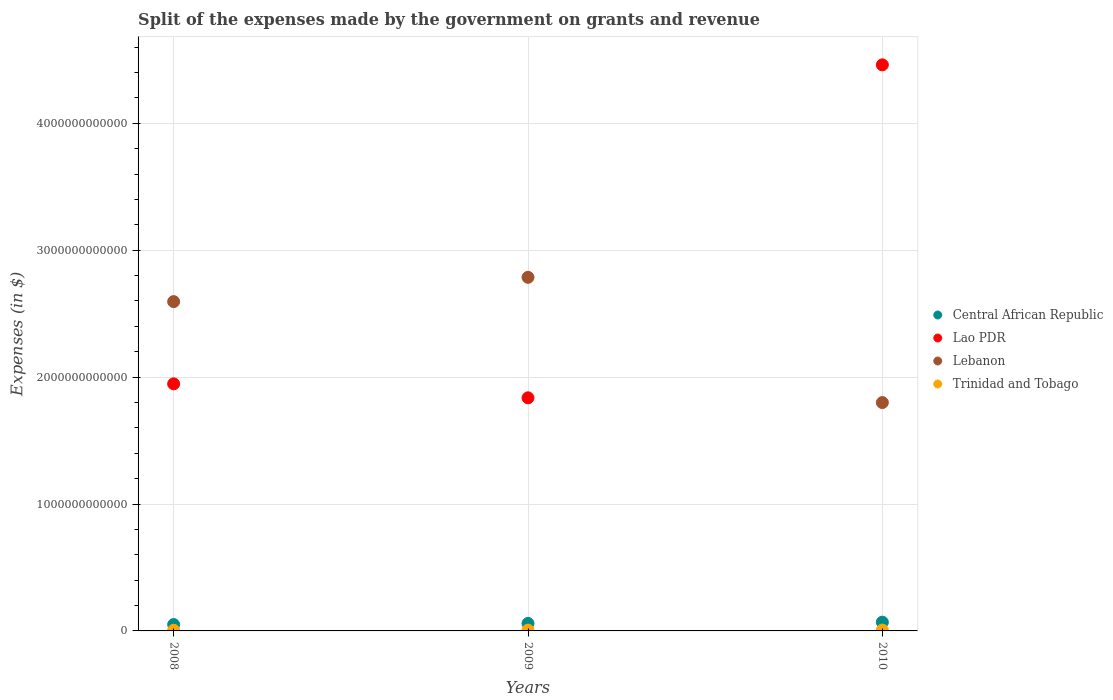Is the number of dotlines equal to the number of legend labels?
Make the answer very short. Yes. What is the expenses made by the government on grants and revenue in Central African Republic in 2008?
Give a very brief answer. 5.01e+1. Across all years, what is the maximum expenses made by the government on grants and revenue in Lao PDR?
Your response must be concise. 4.46e+12. Across all years, what is the minimum expenses made by the government on grants and revenue in Trinidad and Tobago?
Offer a very short reply. 5.11e+09. What is the total expenses made by the government on grants and revenue in Lebanon in the graph?
Ensure brevity in your answer.  7.18e+12. What is the difference between the expenses made by the government on grants and revenue in Lao PDR in 2009 and that in 2010?
Give a very brief answer. -2.62e+12. What is the difference between the expenses made by the government on grants and revenue in Central African Republic in 2009 and the expenses made by the government on grants and revenue in Trinidad and Tobago in 2010?
Keep it short and to the point. 5.21e+1. What is the average expenses made by the government on grants and revenue in Lebanon per year?
Make the answer very short. 2.39e+12. In the year 2008, what is the difference between the expenses made by the government on grants and revenue in Lebanon and expenses made by the government on grants and revenue in Trinidad and Tobago?
Provide a short and direct response. 2.59e+12. What is the ratio of the expenses made by the government on grants and revenue in Lao PDR in 2009 to that in 2010?
Offer a terse response. 0.41. What is the difference between the highest and the second highest expenses made by the government on grants and revenue in Central African Republic?
Your answer should be very brief. 1.01e+1. What is the difference between the highest and the lowest expenses made by the government on grants and revenue in Trinidad and Tobago?
Provide a succinct answer. 1.63e+09. Is it the case that in every year, the sum of the expenses made by the government on grants and revenue in Central African Republic and expenses made by the government on grants and revenue in Trinidad and Tobago  is greater than the expenses made by the government on grants and revenue in Lebanon?
Make the answer very short. No. Does the expenses made by the government on grants and revenue in Lebanon monotonically increase over the years?
Ensure brevity in your answer.  No. Is the expenses made by the government on grants and revenue in Trinidad and Tobago strictly greater than the expenses made by the government on grants and revenue in Lao PDR over the years?
Your answer should be very brief. No. Is the expenses made by the government on grants and revenue in Central African Republic strictly less than the expenses made by the government on grants and revenue in Lao PDR over the years?
Give a very brief answer. Yes. How many dotlines are there?
Keep it short and to the point. 4. What is the difference between two consecutive major ticks on the Y-axis?
Give a very brief answer. 1.00e+12. Are the values on the major ticks of Y-axis written in scientific E-notation?
Make the answer very short. No. Does the graph contain grids?
Provide a short and direct response. Yes. Where does the legend appear in the graph?
Provide a short and direct response. Center right. How many legend labels are there?
Make the answer very short. 4. What is the title of the graph?
Provide a succinct answer. Split of the expenses made by the government on grants and revenue. What is the label or title of the Y-axis?
Your response must be concise. Expenses (in $). What is the Expenses (in $) in Central African Republic in 2008?
Offer a very short reply. 5.01e+1. What is the Expenses (in $) of Lao PDR in 2008?
Provide a short and direct response. 1.95e+12. What is the Expenses (in $) in Lebanon in 2008?
Provide a succinct answer. 2.59e+12. What is the Expenses (in $) in Trinidad and Tobago in 2008?
Your answer should be compact. 5.11e+09. What is the Expenses (in $) of Central African Republic in 2009?
Your answer should be compact. 5.88e+1. What is the Expenses (in $) of Lao PDR in 2009?
Ensure brevity in your answer.  1.84e+12. What is the Expenses (in $) of Lebanon in 2009?
Offer a terse response. 2.79e+12. What is the Expenses (in $) in Trinidad and Tobago in 2009?
Make the answer very short. 6.45e+09. What is the Expenses (in $) of Central African Republic in 2010?
Provide a succinct answer. 6.89e+1. What is the Expenses (in $) in Lao PDR in 2010?
Your answer should be very brief. 4.46e+12. What is the Expenses (in $) in Lebanon in 2010?
Provide a succinct answer. 1.80e+12. What is the Expenses (in $) of Trinidad and Tobago in 2010?
Your answer should be compact. 6.74e+09. Across all years, what is the maximum Expenses (in $) of Central African Republic?
Your response must be concise. 6.89e+1. Across all years, what is the maximum Expenses (in $) of Lao PDR?
Make the answer very short. 4.46e+12. Across all years, what is the maximum Expenses (in $) in Lebanon?
Provide a succinct answer. 2.79e+12. Across all years, what is the maximum Expenses (in $) of Trinidad and Tobago?
Offer a very short reply. 6.74e+09. Across all years, what is the minimum Expenses (in $) of Central African Republic?
Offer a terse response. 5.01e+1. Across all years, what is the minimum Expenses (in $) in Lao PDR?
Provide a short and direct response. 1.84e+12. Across all years, what is the minimum Expenses (in $) in Lebanon?
Make the answer very short. 1.80e+12. Across all years, what is the minimum Expenses (in $) of Trinidad and Tobago?
Give a very brief answer. 5.11e+09. What is the total Expenses (in $) of Central African Republic in the graph?
Your response must be concise. 1.78e+11. What is the total Expenses (in $) of Lao PDR in the graph?
Give a very brief answer. 8.24e+12. What is the total Expenses (in $) of Lebanon in the graph?
Your answer should be compact. 7.18e+12. What is the total Expenses (in $) in Trinidad and Tobago in the graph?
Provide a short and direct response. 1.83e+1. What is the difference between the Expenses (in $) of Central African Republic in 2008 and that in 2009?
Offer a very short reply. -8.74e+09. What is the difference between the Expenses (in $) of Lao PDR in 2008 and that in 2009?
Offer a terse response. 1.10e+11. What is the difference between the Expenses (in $) in Lebanon in 2008 and that in 2009?
Make the answer very short. -1.91e+11. What is the difference between the Expenses (in $) in Trinidad and Tobago in 2008 and that in 2009?
Offer a very short reply. -1.34e+09. What is the difference between the Expenses (in $) in Central African Republic in 2008 and that in 2010?
Ensure brevity in your answer.  -1.88e+1. What is the difference between the Expenses (in $) of Lao PDR in 2008 and that in 2010?
Your response must be concise. -2.51e+12. What is the difference between the Expenses (in $) in Lebanon in 2008 and that in 2010?
Offer a very short reply. 7.95e+11. What is the difference between the Expenses (in $) of Trinidad and Tobago in 2008 and that in 2010?
Offer a terse response. -1.63e+09. What is the difference between the Expenses (in $) of Central African Republic in 2009 and that in 2010?
Your response must be concise. -1.01e+1. What is the difference between the Expenses (in $) in Lao PDR in 2009 and that in 2010?
Ensure brevity in your answer.  -2.62e+12. What is the difference between the Expenses (in $) in Lebanon in 2009 and that in 2010?
Give a very brief answer. 9.87e+11. What is the difference between the Expenses (in $) in Trinidad and Tobago in 2009 and that in 2010?
Your answer should be compact. -2.85e+08. What is the difference between the Expenses (in $) in Central African Republic in 2008 and the Expenses (in $) in Lao PDR in 2009?
Your response must be concise. -1.79e+12. What is the difference between the Expenses (in $) of Central African Republic in 2008 and the Expenses (in $) of Lebanon in 2009?
Offer a terse response. -2.74e+12. What is the difference between the Expenses (in $) in Central African Republic in 2008 and the Expenses (in $) in Trinidad and Tobago in 2009?
Provide a succinct answer. 4.36e+1. What is the difference between the Expenses (in $) in Lao PDR in 2008 and the Expenses (in $) in Lebanon in 2009?
Your answer should be very brief. -8.39e+11. What is the difference between the Expenses (in $) of Lao PDR in 2008 and the Expenses (in $) of Trinidad and Tobago in 2009?
Ensure brevity in your answer.  1.94e+12. What is the difference between the Expenses (in $) of Lebanon in 2008 and the Expenses (in $) of Trinidad and Tobago in 2009?
Provide a succinct answer. 2.59e+12. What is the difference between the Expenses (in $) in Central African Republic in 2008 and the Expenses (in $) in Lao PDR in 2010?
Provide a succinct answer. -4.41e+12. What is the difference between the Expenses (in $) in Central African Republic in 2008 and the Expenses (in $) in Lebanon in 2010?
Your answer should be compact. -1.75e+12. What is the difference between the Expenses (in $) of Central African Republic in 2008 and the Expenses (in $) of Trinidad and Tobago in 2010?
Your response must be concise. 4.33e+1. What is the difference between the Expenses (in $) of Lao PDR in 2008 and the Expenses (in $) of Lebanon in 2010?
Give a very brief answer. 1.48e+11. What is the difference between the Expenses (in $) in Lao PDR in 2008 and the Expenses (in $) in Trinidad and Tobago in 2010?
Offer a terse response. 1.94e+12. What is the difference between the Expenses (in $) in Lebanon in 2008 and the Expenses (in $) in Trinidad and Tobago in 2010?
Make the answer very short. 2.59e+12. What is the difference between the Expenses (in $) of Central African Republic in 2009 and the Expenses (in $) of Lao PDR in 2010?
Ensure brevity in your answer.  -4.40e+12. What is the difference between the Expenses (in $) in Central African Republic in 2009 and the Expenses (in $) in Lebanon in 2010?
Your answer should be very brief. -1.74e+12. What is the difference between the Expenses (in $) of Central African Republic in 2009 and the Expenses (in $) of Trinidad and Tobago in 2010?
Give a very brief answer. 5.21e+1. What is the difference between the Expenses (in $) in Lao PDR in 2009 and the Expenses (in $) in Lebanon in 2010?
Offer a terse response. 3.72e+1. What is the difference between the Expenses (in $) of Lao PDR in 2009 and the Expenses (in $) of Trinidad and Tobago in 2010?
Offer a very short reply. 1.83e+12. What is the difference between the Expenses (in $) in Lebanon in 2009 and the Expenses (in $) in Trinidad and Tobago in 2010?
Ensure brevity in your answer.  2.78e+12. What is the average Expenses (in $) of Central African Republic per year?
Provide a succinct answer. 5.93e+1. What is the average Expenses (in $) in Lao PDR per year?
Make the answer very short. 2.75e+12. What is the average Expenses (in $) in Lebanon per year?
Your answer should be compact. 2.39e+12. What is the average Expenses (in $) of Trinidad and Tobago per year?
Your response must be concise. 6.10e+09. In the year 2008, what is the difference between the Expenses (in $) of Central African Republic and Expenses (in $) of Lao PDR?
Provide a short and direct response. -1.90e+12. In the year 2008, what is the difference between the Expenses (in $) of Central African Republic and Expenses (in $) of Lebanon?
Keep it short and to the point. -2.54e+12. In the year 2008, what is the difference between the Expenses (in $) in Central African Republic and Expenses (in $) in Trinidad and Tobago?
Your answer should be compact. 4.50e+1. In the year 2008, what is the difference between the Expenses (in $) in Lao PDR and Expenses (in $) in Lebanon?
Provide a short and direct response. -6.48e+11. In the year 2008, what is the difference between the Expenses (in $) of Lao PDR and Expenses (in $) of Trinidad and Tobago?
Offer a terse response. 1.94e+12. In the year 2008, what is the difference between the Expenses (in $) of Lebanon and Expenses (in $) of Trinidad and Tobago?
Provide a short and direct response. 2.59e+12. In the year 2009, what is the difference between the Expenses (in $) in Central African Republic and Expenses (in $) in Lao PDR?
Your response must be concise. -1.78e+12. In the year 2009, what is the difference between the Expenses (in $) in Central African Republic and Expenses (in $) in Lebanon?
Provide a succinct answer. -2.73e+12. In the year 2009, what is the difference between the Expenses (in $) in Central African Republic and Expenses (in $) in Trinidad and Tobago?
Keep it short and to the point. 5.24e+1. In the year 2009, what is the difference between the Expenses (in $) in Lao PDR and Expenses (in $) in Lebanon?
Provide a short and direct response. -9.50e+11. In the year 2009, what is the difference between the Expenses (in $) in Lao PDR and Expenses (in $) in Trinidad and Tobago?
Your answer should be very brief. 1.83e+12. In the year 2009, what is the difference between the Expenses (in $) in Lebanon and Expenses (in $) in Trinidad and Tobago?
Your response must be concise. 2.78e+12. In the year 2010, what is the difference between the Expenses (in $) in Central African Republic and Expenses (in $) in Lao PDR?
Offer a terse response. -4.39e+12. In the year 2010, what is the difference between the Expenses (in $) of Central African Republic and Expenses (in $) of Lebanon?
Your answer should be compact. -1.73e+12. In the year 2010, what is the difference between the Expenses (in $) of Central African Republic and Expenses (in $) of Trinidad and Tobago?
Provide a succinct answer. 6.22e+1. In the year 2010, what is the difference between the Expenses (in $) in Lao PDR and Expenses (in $) in Lebanon?
Give a very brief answer. 2.66e+12. In the year 2010, what is the difference between the Expenses (in $) of Lao PDR and Expenses (in $) of Trinidad and Tobago?
Offer a very short reply. 4.45e+12. In the year 2010, what is the difference between the Expenses (in $) of Lebanon and Expenses (in $) of Trinidad and Tobago?
Your response must be concise. 1.79e+12. What is the ratio of the Expenses (in $) in Central African Republic in 2008 to that in 2009?
Provide a succinct answer. 0.85. What is the ratio of the Expenses (in $) of Lao PDR in 2008 to that in 2009?
Make the answer very short. 1.06. What is the ratio of the Expenses (in $) in Lebanon in 2008 to that in 2009?
Your answer should be very brief. 0.93. What is the ratio of the Expenses (in $) in Trinidad and Tobago in 2008 to that in 2009?
Offer a terse response. 0.79. What is the ratio of the Expenses (in $) of Central African Republic in 2008 to that in 2010?
Ensure brevity in your answer.  0.73. What is the ratio of the Expenses (in $) of Lao PDR in 2008 to that in 2010?
Offer a very short reply. 0.44. What is the ratio of the Expenses (in $) in Lebanon in 2008 to that in 2010?
Your answer should be very brief. 1.44. What is the ratio of the Expenses (in $) in Trinidad and Tobago in 2008 to that in 2010?
Give a very brief answer. 0.76. What is the ratio of the Expenses (in $) in Central African Republic in 2009 to that in 2010?
Ensure brevity in your answer.  0.85. What is the ratio of the Expenses (in $) of Lao PDR in 2009 to that in 2010?
Ensure brevity in your answer.  0.41. What is the ratio of the Expenses (in $) of Lebanon in 2009 to that in 2010?
Keep it short and to the point. 1.55. What is the ratio of the Expenses (in $) of Trinidad and Tobago in 2009 to that in 2010?
Offer a terse response. 0.96. What is the difference between the highest and the second highest Expenses (in $) of Central African Republic?
Make the answer very short. 1.01e+1. What is the difference between the highest and the second highest Expenses (in $) in Lao PDR?
Ensure brevity in your answer.  2.51e+12. What is the difference between the highest and the second highest Expenses (in $) of Lebanon?
Your answer should be compact. 1.91e+11. What is the difference between the highest and the second highest Expenses (in $) of Trinidad and Tobago?
Offer a very short reply. 2.85e+08. What is the difference between the highest and the lowest Expenses (in $) in Central African Republic?
Give a very brief answer. 1.88e+1. What is the difference between the highest and the lowest Expenses (in $) of Lao PDR?
Keep it short and to the point. 2.62e+12. What is the difference between the highest and the lowest Expenses (in $) in Lebanon?
Make the answer very short. 9.87e+11. What is the difference between the highest and the lowest Expenses (in $) of Trinidad and Tobago?
Offer a terse response. 1.63e+09. 